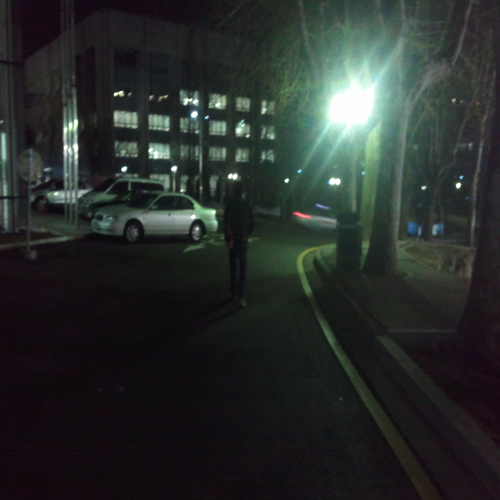What suggestions would you give to improve the quality of this photograph? Improving the photograph could involve increasing the light exposure to reduce noise and graininess. A steadier hand or a tripod could also enhance clarity, preventing blur. Additionally, adjusting the focus to ensure that the main subject is sharp, and experimenting with different angles or compositions could potentially make the image more impactful. 